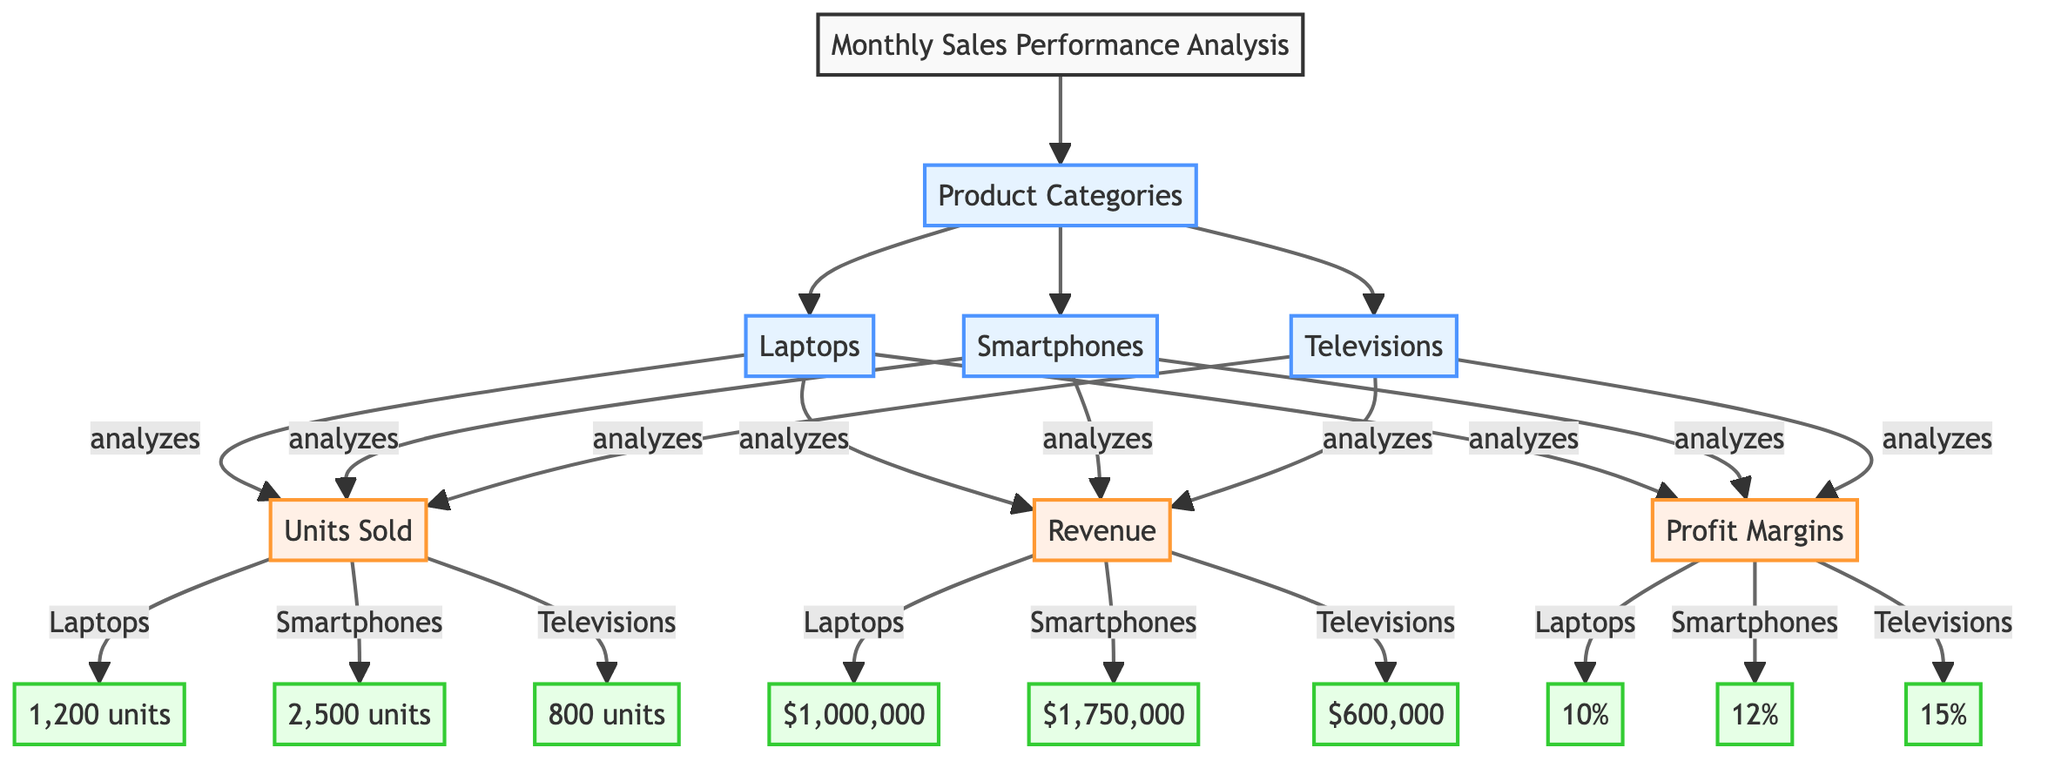What is the total number of product categories in the diagram? The diagram displays three distinct product categories: Laptops, Smartphones, and Televisions. The connection links under "Product Categories" indicate each category clearly.
Answer: 3 What is the profit margin for Smartphones? By locating the Smartphones category, we can find that the corresponding profit margin displayed is 12%. This is indicated by the connection from "Smartphones" to the profit margin node.
Answer: 12% How many units of Televisions were sold? The Televisions category shows a direct link to the units sold, which is indicated as 800 units in the diagram. This connection leads directly to the numeric information.
Answer: 800 units What is the revenue generated from Laptops sales? The revenue linked to the Laptops category is $1,000,000 as shown in the diagram, indicated by the arrow connecting "Laptops" to the revenue node.
Answer: $1,000,000 Which product category has the highest profit margin? By comparing the profit margins of all three categories, Laptops has a profit margin of 10%, Smartphones has 12%, and Televisions has 15%. The highest margin can be identified from these values, leading to Televisions as the category with the largest percentage.
Answer: Televisions How many more units were sold for Smartphones compared to Laptops? The number of units sold for Smartphones is 2,500, and for Laptops, it is 1,200 units. By subtracting the units sold for Laptops from those sold for Smartphones (2,500 - 1,200), we determine the difference.
Answer: 1,300 units What is the relationship between the revenue and profit margin for Televisions? The revenue for Televisions is $600,000 and the profit margin is 15%. This indicates a secondary relationship as they are linked to the Televisions category, showing how profit margins can be derived from revenue in a business context.
Answer: Revenue of $600,000 and profit margin of 15% What is the range of units sold among all product categories? The units sold for the three categories are as follows: Laptops at 1,200 units, Smartphones at 2,500 units, and Televisions at 800 units. The range can be calculated as the difference between the maximum (2,500) and minimum (800), which provides insight into sales performance variance.
Answer: 1,700 units What class is assigned to the data nodes in the diagram? In the diagram, each data node representing specifics like units sold, revenue, and profit margins is assigned the "data" class. This classification differentiates it from the metric and category classes.
Answer: Data 